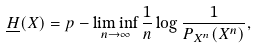<formula> <loc_0><loc_0><loc_500><loc_500>\underline { H } ( { X } ) = p - \liminf _ { n \to \infty } \frac { 1 } { n } \log \frac { 1 } { P _ { X ^ { n } } ( X ^ { n } ) } ,</formula> 